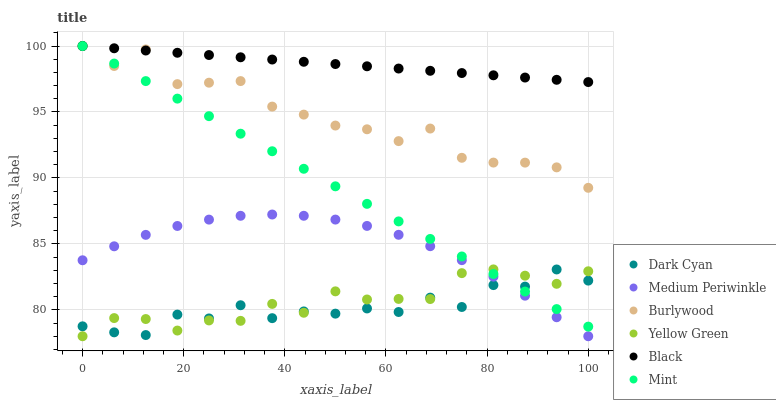Does Dark Cyan have the minimum area under the curve?
Answer yes or no. Yes. Does Black have the maximum area under the curve?
Answer yes or no. Yes. Does Burlywood have the minimum area under the curve?
Answer yes or no. No. Does Burlywood have the maximum area under the curve?
Answer yes or no. No. Is Black the smoothest?
Answer yes or no. Yes. Is Burlywood the roughest?
Answer yes or no. Yes. Is Medium Periwinkle the smoothest?
Answer yes or no. No. Is Medium Periwinkle the roughest?
Answer yes or no. No. Does Yellow Green have the lowest value?
Answer yes or no. Yes. Does Burlywood have the lowest value?
Answer yes or no. No. Does Mint have the highest value?
Answer yes or no. Yes. Does Medium Periwinkle have the highest value?
Answer yes or no. No. Is Dark Cyan less than Burlywood?
Answer yes or no. Yes. Is Black greater than Dark Cyan?
Answer yes or no. Yes. Does Black intersect Mint?
Answer yes or no. Yes. Is Black less than Mint?
Answer yes or no. No. Is Black greater than Mint?
Answer yes or no. No. Does Dark Cyan intersect Burlywood?
Answer yes or no. No. 